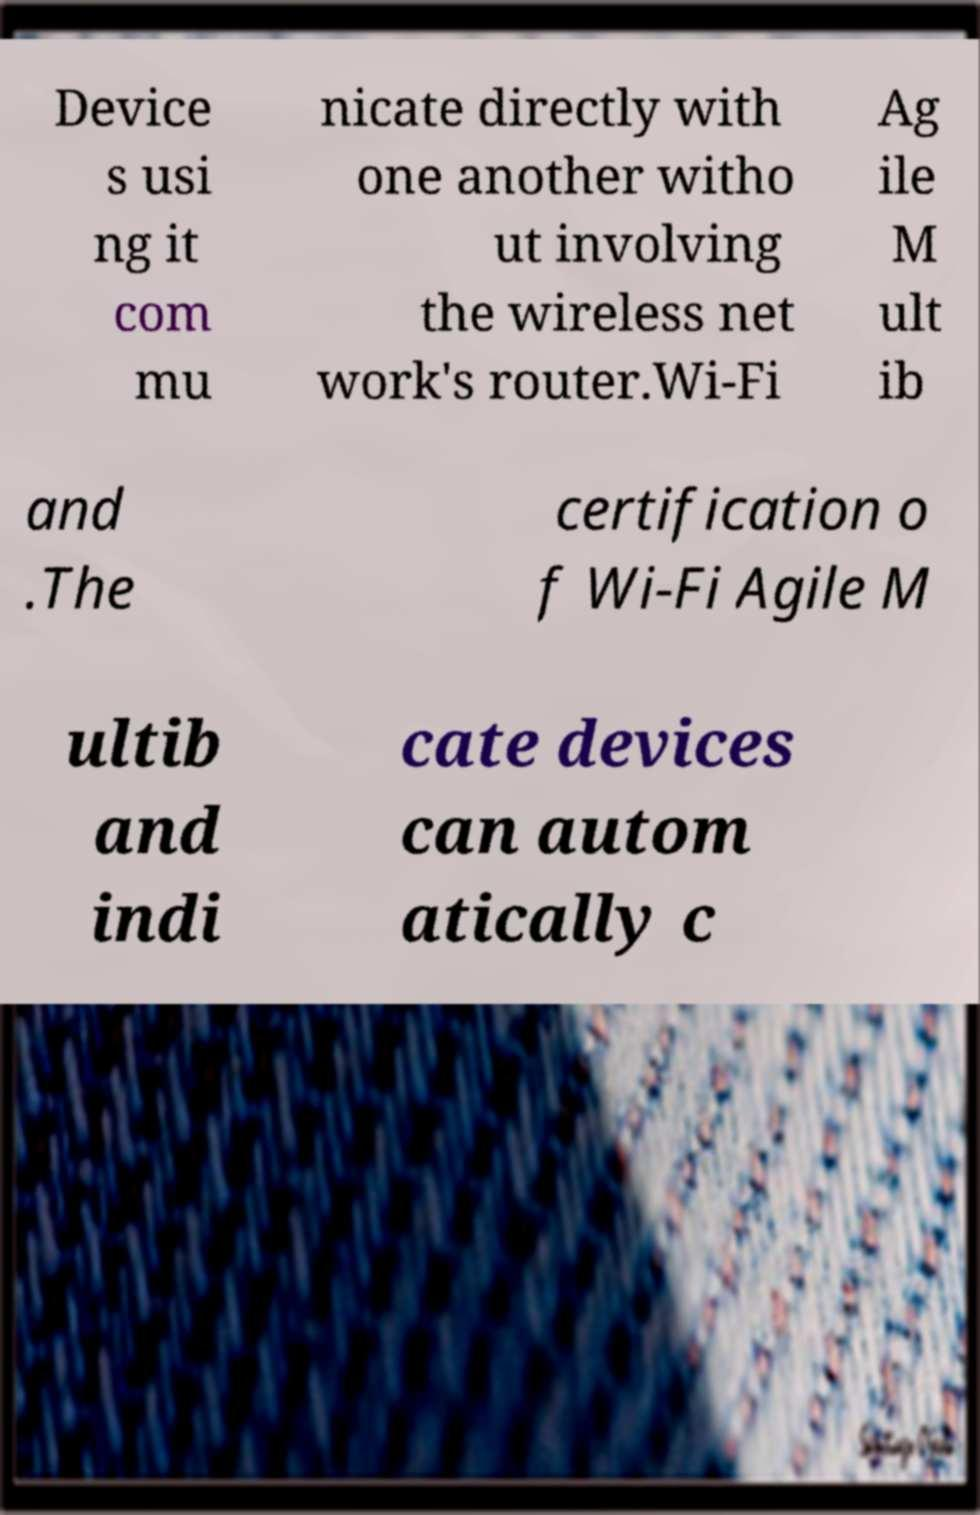For documentation purposes, I need the text within this image transcribed. Could you provide that? Device s usi ng it com mu nicate directly with one another witho ut involving the wireless net work's router.Wi-Fi Ag ile M ult ib and .The certification o f Wi-Fi Agile M ultib and indi cate devices can autom atically c 